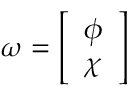Convert formula to latex. <formula><loc_0><loc_0><loc_500><loc_500>\omega = { \left [ \begin{array} { l } { \phi } \\ { \chi } \end{array} \right ] }</formula> 